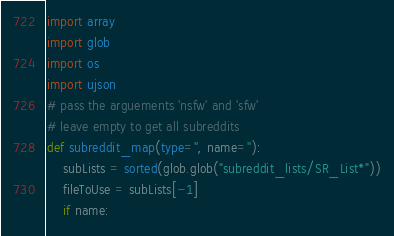Convert code to text. <code><loc_0><loc_0><loc_500><loc_500><_Python_>import array
import glob
import os
import ujson
# pass the arguements 'nsfw' and 'sfw'
# leave empty to get all subreddits
def subreddit_map(type='', name=''):
    subLists = sorted(glob.glob("subreddit_lists/SR_List*"))
    fileToUse = subLists[-1]
    if name:</code> 